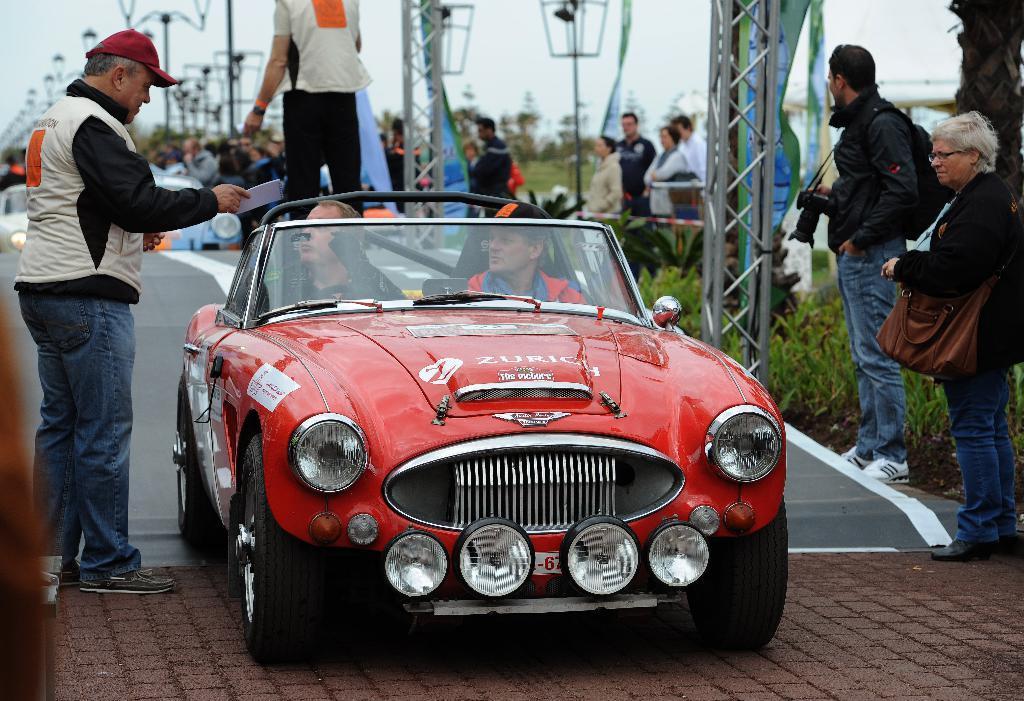Can you describe this image briefly? In this picture two people are sitting inside a red car and a guy is giving a document to them. To the right side of the image we observe two people standing and in the background there are many lights and few people sitting on the road. 